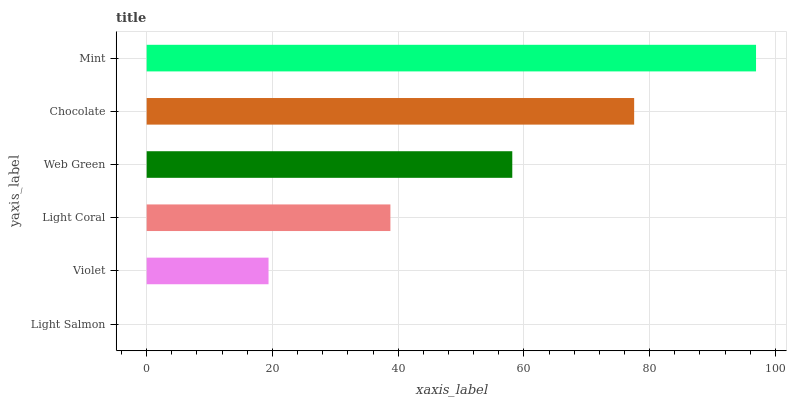Is Light Salmon the minimum?
Answer yes or no. Yes. Is Mint the maximum?
Answer yes or no. Yes. Is Violet the minimum?
Answer yes or no. No. Is Violet the maximum?
Answer yes or no. No. Is Violet greater than Light Salmon?
Answer yes or no. Yes. Is Light Salmon less than Violet?
Answer yes or no. Yes. Is Light Salmon greater than Violet?
Answer yes or no. No. Is Violet less than Light Salmon?
Answer yes or no. No. Is Web Green the high median?
Answer yes or no. Yes. Is Light Coral the low median?
Answer yes or no. Yes. Is Mint the high median?
Answer yes or no. No. Is Web Green the low median?
Answer yes or no. No. 